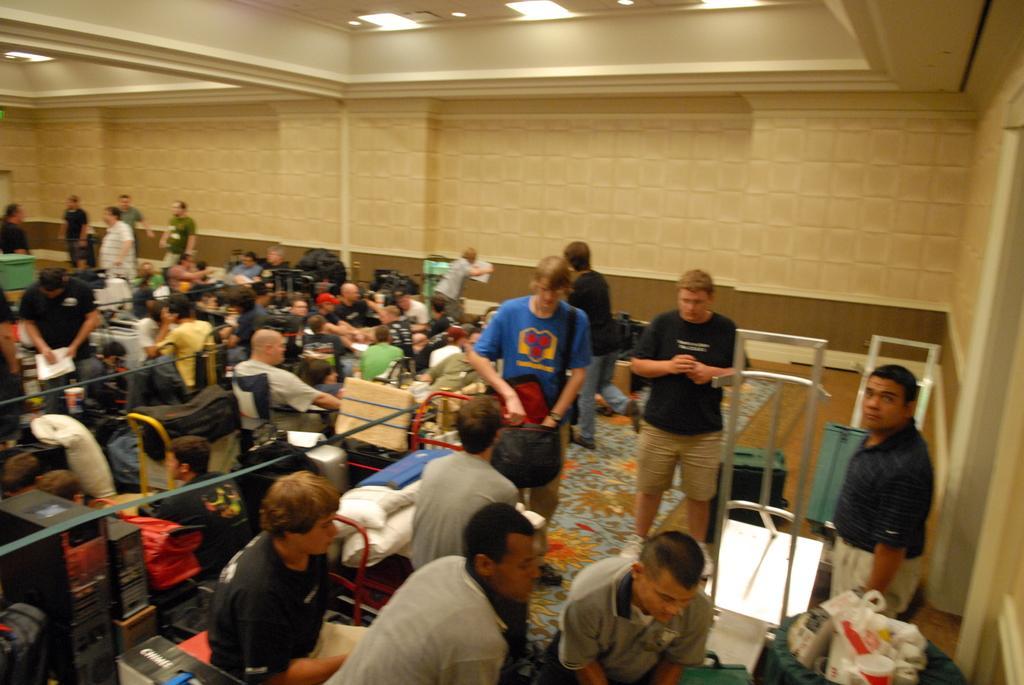Please provide a concise description of this image. In this image I can see group of people, some are sitting and some are standing. In front the person is wearing blue and cream color dress. In the background I can see few lights and the wall is in cream color. 